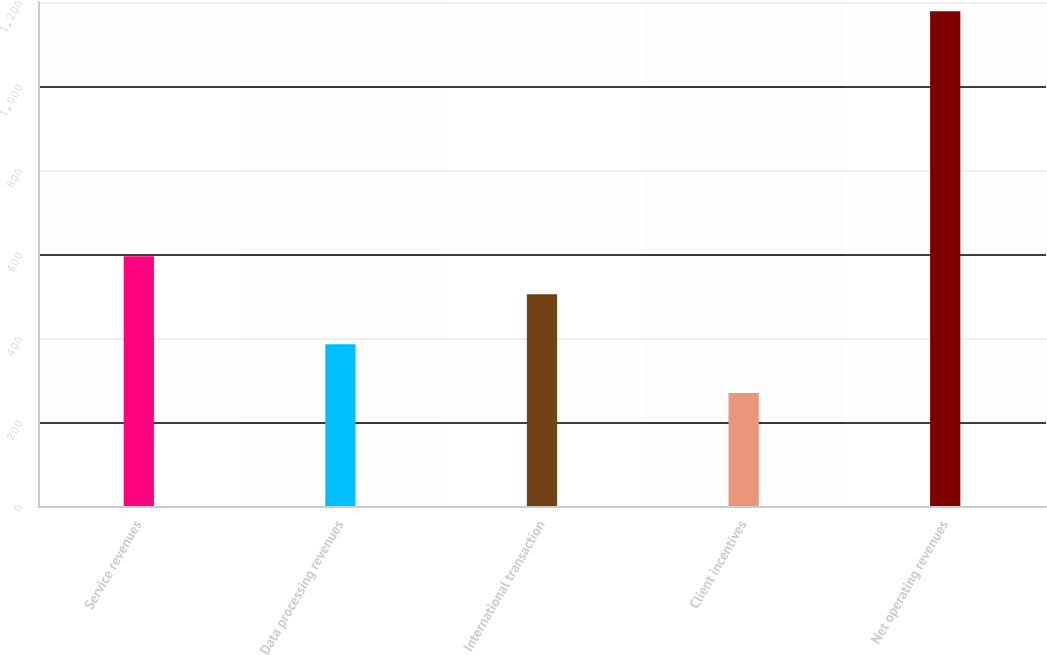Convert chart. <chart><loc_0><loc_0><loc_500><loc_500><bar_chart><fcel>Service revenues<fcel>Data processing revenues<fcel>International transaction<fcel>Client incentives<fcel>Net operating revenues<nl><fcel>594.9<fcel>385<fcel>504<fcel>269<fcel>1178<nl></chart> 